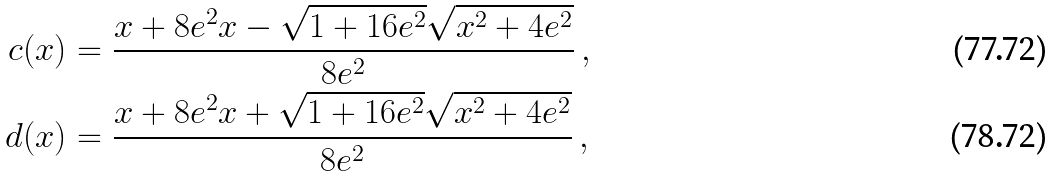Convert formula to latex. <formula><loc_0><loc_0><loc_500><loc_500>c ( x ) & = \frac { x + 8 e ^ { 2 } x - \sqrt { 1 + 1 6 e ^ { 2 } } \sqrt { x ^ { 2 } + 4 e ^ { 2 } } } { 8 e ^ { 2 } } \, , \\ d ( x ) & = \frac { x + 8 e ^ { 2 } x + \sqrt { 1 + 1 6 e ^ { 2 } } \sqrt { x ^ { 2 } + 4 e ^ { 2 } } } { 8 e ^ { 2 } } \, ,</formula> 